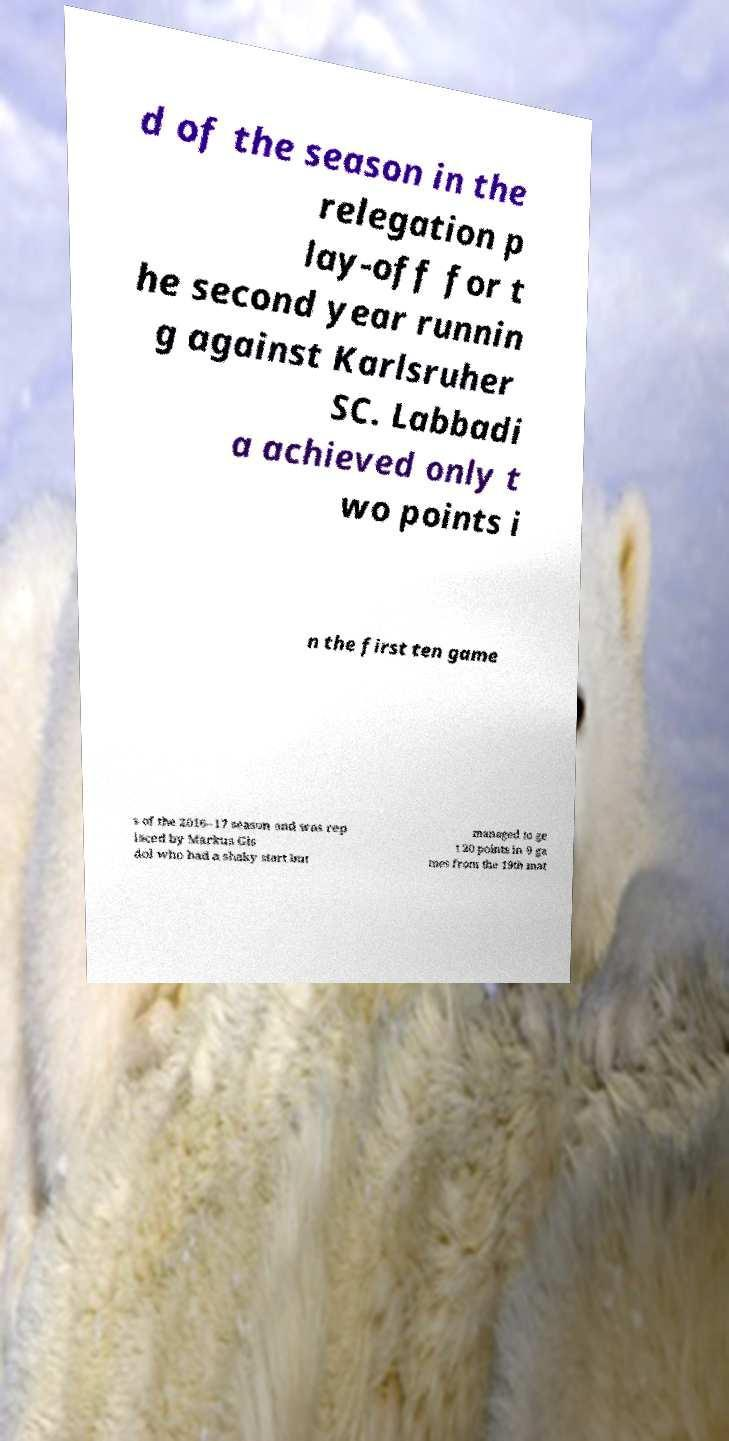Can you accurately transcribe the text from the provided image for me? d of the season in the relegation p lay-off for t he second year runnin g against Karlsruher SC. Labbadi a achieved only t wo points i n the first ten game s of the 2016–17 season and was rep laced by Markus Gis dol who had a shaky start but managed to ge t 20 points in 9 ga mes from the 19th mat 